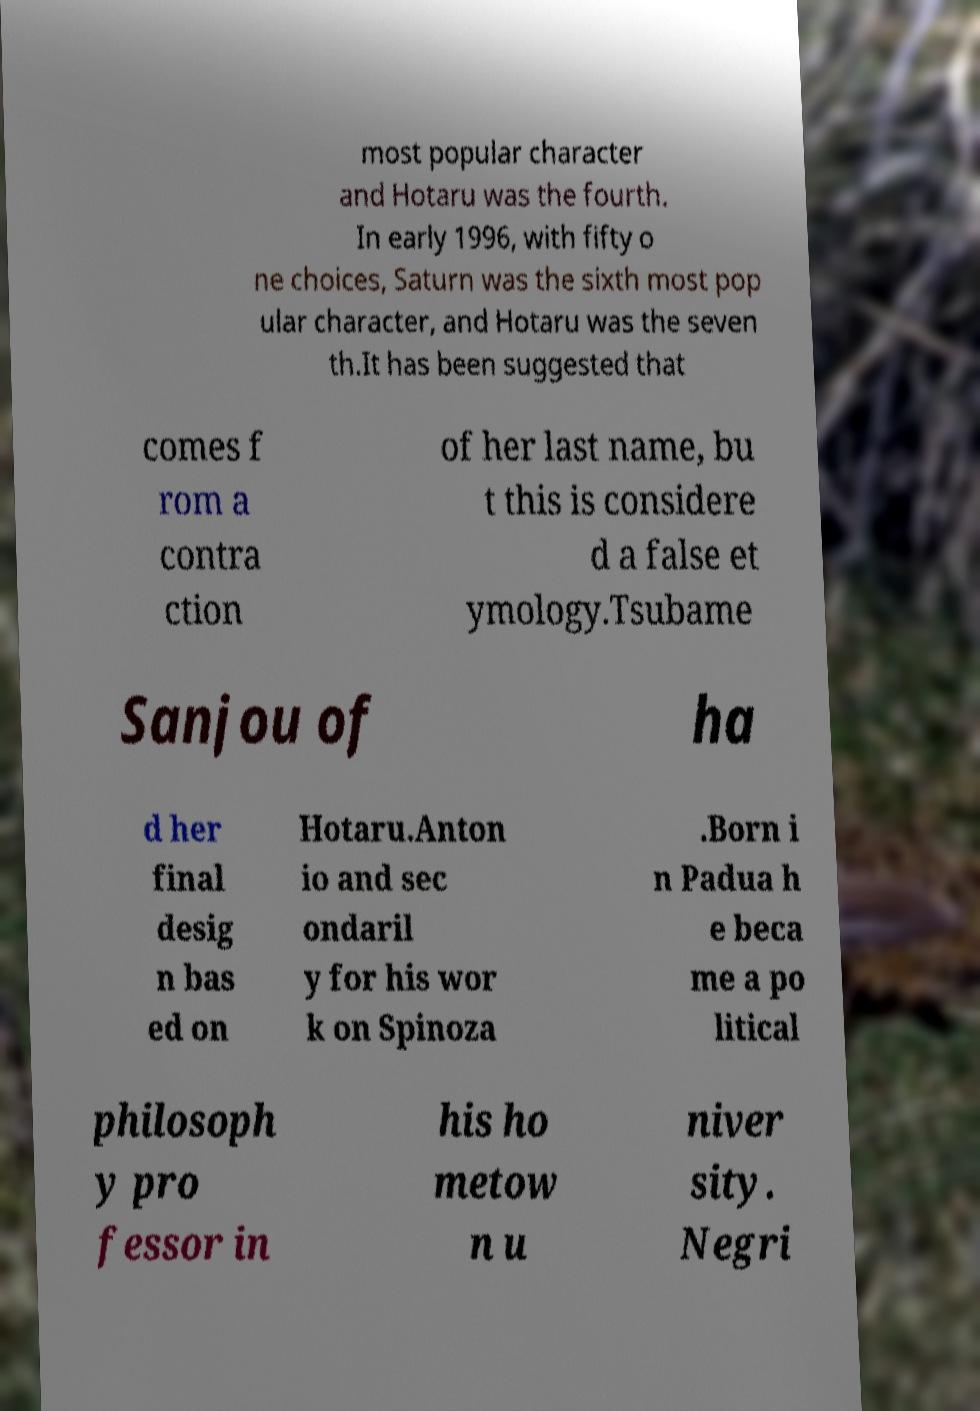Please identify and transcribe the text found in this image. most popular character and Hotaru was the fourth. In early 1996, with fifty o ne choices, Saturn was the sixth most pop ular character, and Hotaru was the seven th.It has been suggested that comes f rom a contra ction of her last name, bu t this is considere d a false et ymology.Tsubame Sanjou of ha d her final desig n bas ed on Hotaru.Anton io and sec ondaril y for his wor k on Spinoza .Born i n Padua h e beca me a po litical philosoph y pro fessor in his ho metow n u niver sity. Negri 